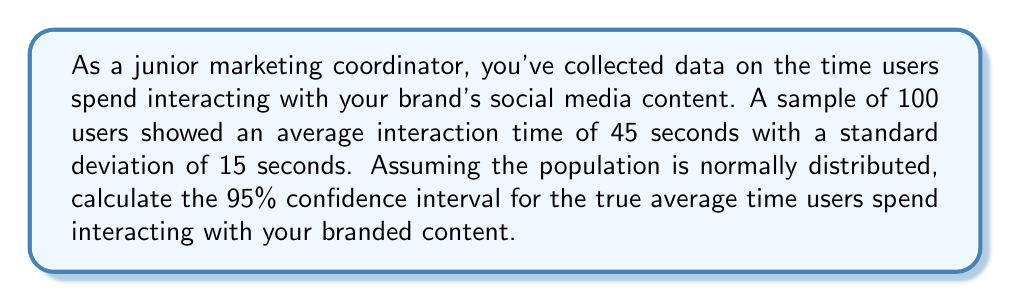Solve this math problem. To calculate the confidence interval, we'll follow these steps:

1. Identify the given information:
   - Sample size: $n = 100$
   - Sample mean: $\bar{x} = 45$ seconds
   - Sample standard deviation: $s = 15$ seconds
   - Confidence level: 95% (α = 0.05)

2. Find the critical value ($z_{\alpha/2}$) for a 95% confidence interval:
   $z_{\alpha/2} = 1.96$ (from the standard normal distribution table)

3. Calculate the standard error (SE) of the mean:
   $$SE = \frac{s}{\sqrt{n}} = \frac{15}{\sqrt{100}} = \frac{15}{10} = 1.5$$

4. Compute the margin of error (ME):
   $$ME = z_{\alpha/2} \times SE = 1.96 \times 1.5 = 2.94$$

5. Calculate the confidence interval:
   Lower bound: $\bar{x} - ME = 45 - 2.94 = 42.06$ seconds
   Upper bound: $\bar{x} + ME = 45 + 2.94 = 47.94$ seconds

Therefore, the 95% confidence interval for the true average time users spend interacting with your branded content is (42.06 seconds, 47.94 seconds).
Answer: (42.06, 47.94) seconds 